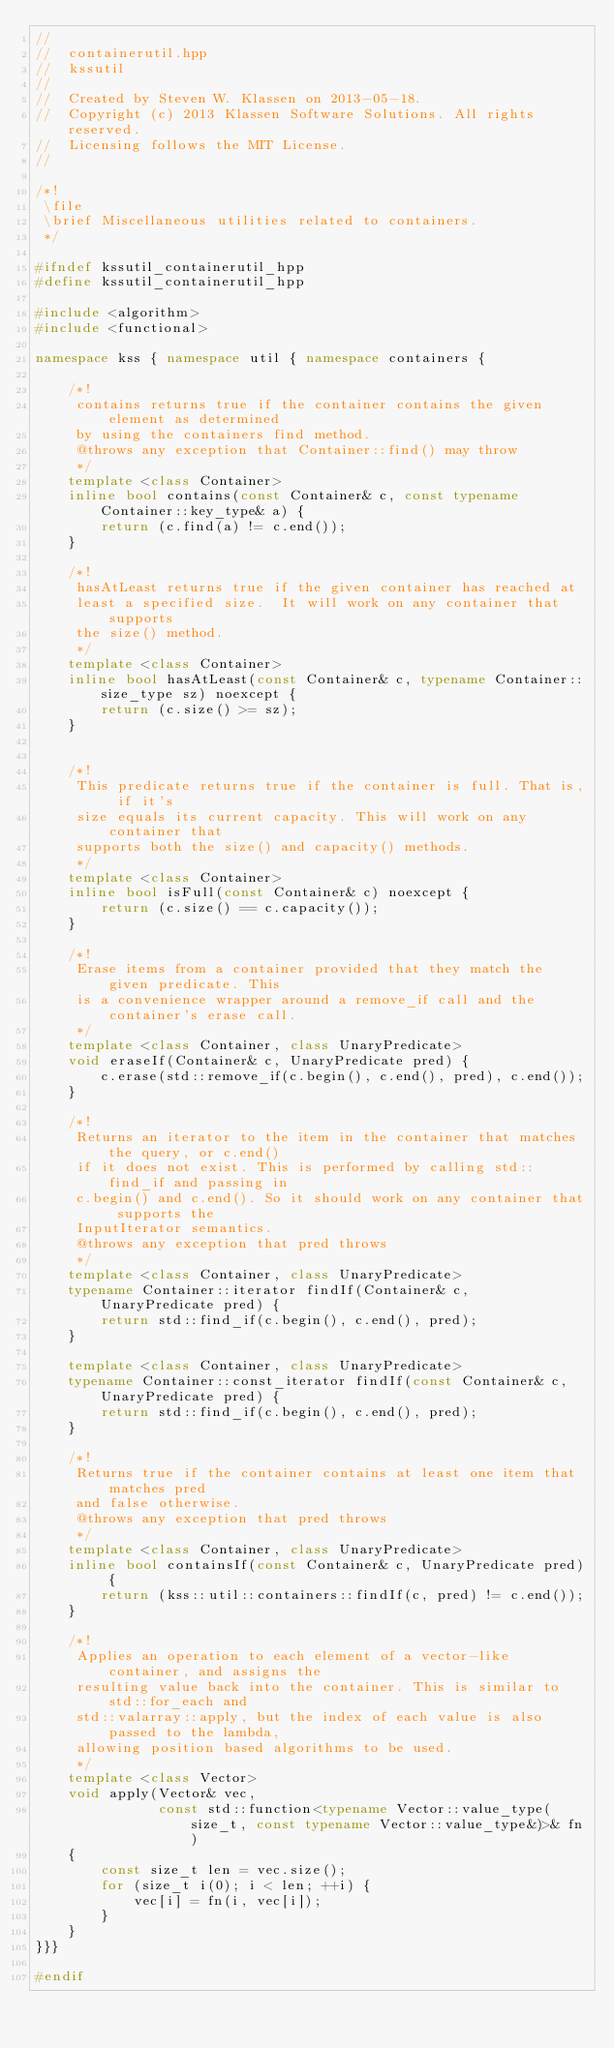<code> <loc_0><loc_0><loc_500><loc_500><_C++_>//
//  containerutil.hpp
//  kssutil
//
//  Created by Steven W. Klassen on 2013-05-18.
//  Copyright (c) 2013 Klassen Software Solutions. All rights reserved.
//  Licensing follows the MIT License.
//

/*!
 \file
 \brief Miscellaneous utilities related to containers.
 */

#ifndef kssutil_containerutil_hpp
#define kssutil_containerutil_hpp

#include <algorithm>
#include <functional>

namespace kss { namespace util { namespace containers {

    /*!
     contains returns true if the container contains the given element as determined
     by using the containers find method.
     @throws any exception that Container::find() may throw
     */
    template <class Container>
    inline bool contains(const Container& c, const typename Container::key_type& a) {
        return (c.find(a) != c.end());
    }

    /*!
     hasAtLeast returns true if the given container has reached at
     least a specified size.  It will work on any container that supports
     the size() method.
     */
    template <class Container>
    inline bool hasAtLeast(const Container& c, typename Container::size_type sz) noexcept {
        return (c.size() >= sz);
    }


    /*!
     This predicate returns true if the container is full. That is, if it's
     size equals its current capacity. This will work on any container that
     supports both the size() and capacity() methods.
     */
    template <class Container>
    inline bool isFull(const Container& c) noexcept {
        return (c.size() == c.capacity());
    }

    /*!
     Erase items from a container provided that they match the given predicate. This
     is a convenience wrapper around a remove_if call and the container's erase call.
     */
    template <class Container, class UnaryPredicate>
    void eraseIf(Container& c, UnaryPredicate pred) {
        c.erase(std::remove_if(c.begin(), c.end(), pred), c.end());
    }

    /*!
     Returns an iterator to the item in the container that matches the query, or c.end()
     if it does not exist. This is performed by calling std::find_if and passing in
     c.begin() and c.end(). So it should work on any container that supports the
     InputIterator semantics.
     @throws any exception that pred throws
     */
    template <class Container, class UnaryPredicate>
    typename Container::iterator findIf(Container& c, UnaryPredicate pred) {
        return std::find_if(c.begin(), c.end(), pred);
    }

    template <class Container, class UnaryPredicate>
    typename Container::const_iterator findIf(const Container& c, UnaryPredicate pred) {
        return std::find_if(c.begin(), c.end(), pred);
    }

    /*!
     Returns true if the container contains at least one item that matches pred
     and false otherwise.
     @throws any exception that pred throws
     */
    template <class Container, class UnaryPredicate>
    inline bool containsIf(const Container& c, UnaryPredicate pred) {
        return (kss::util::containers::findIf(c, pred) != c.end());
    }

    /*!
     Applies an operation to each element of a vector-like container, and assigns the
     resulting value back into the container. This is similar to std::for_each and
     std::valarray::apply, but the index of each value is also passed to the lambda,
     allowing position based algorithms to be used.
     */
    template <class Vector>
    void apply(Vector& vec,
               const std::function<typename Vector::value_type(size_t, const typename Vector::value_type&)>& fn)
    {
        const size_t len = vec.size();
        for (size_t i(0); i < len; ++i) {
            vec[i] = fn(i, vec[i]);
        }
    }
}}}

#endif
</code> 